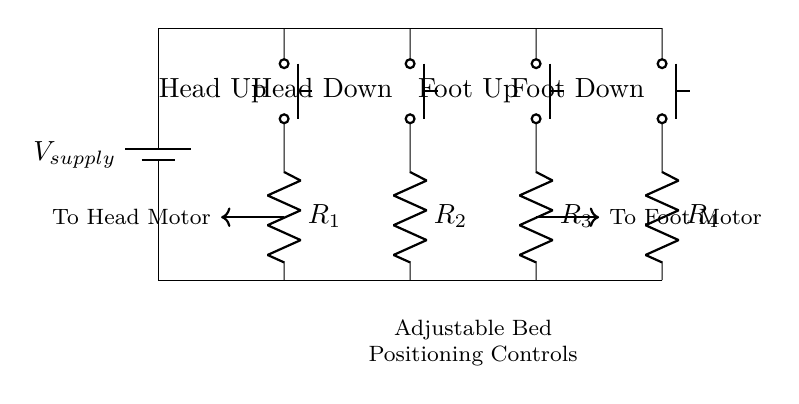What type of circuit is represented? The circuit diagram shows a parallel circuit, where multiple branches (push buttons and resistors) are connected across the same voltage source, allowing for independent operation.
Answer: Parallel circuit How many push buttons are in the circuit? There are four push buttons, labeled Head Up, Head Down, Foot Up, and Foot Down, which control the positioning of the adjustable bed.
Answer: Four What is the purpose of the resistors in this circuit? The resistors (R1, R2, R3, R4) likely limit current flow to the motors that adjust the bed, ensuring that the motors operate within safe parameters.
Answer: Limit current What happens if multiple buttons are pressed simultaneously? If multiple buttons are pressed, the motors will operate concurrently, moving both head and foot sections of the bed at the same time, as they are wired in parallel.
Answer: Concurrent operation What direction does the current flow when the Head Up button is pressed? When the Head Up button is pressed, current flows from the supply voltage through the button (to head motor), following the connection to R1 and then to the motor.
Answer: Upwards to motor Which component directly connects to the head motor? The component that directly connects to the head motor is the Head Up push button, which, when activated, allows current to flow to R1 and then to the motor.
Answer: Head Up push button How is the adjustable bed positioning controlled in this circuit? The adjustable bed positioning is controlled by the activation of individual push buttons, which complete the circuit for either the head or foot motor, allowing for specific positions to be set.
Answer: Individual push buttons 